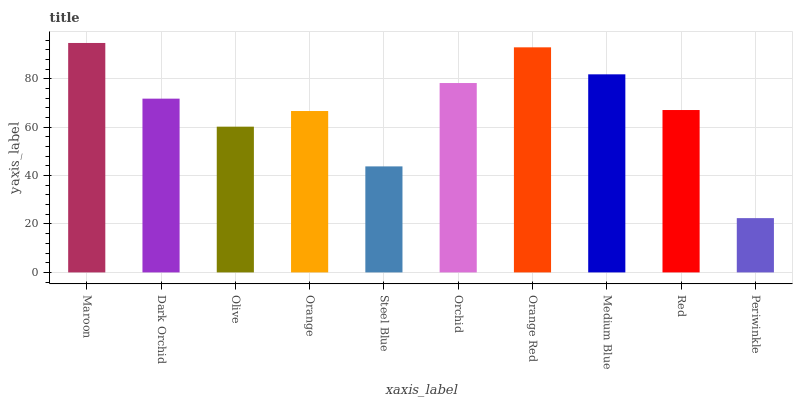Is Periwinkle the minimum?
Answer yes or no. Yes. Is Maroon the maximum?
Answer yes or no. Yes. Is Dark Orchid the minimum?
Answer yes or no. No. Is Dark Orchid the maximum?
Answer yes or no. No. Is Maroon greater than Dark Orchid?
Answer yes or no. Yes. Is Dark Orchid less than Maroon?
Answer yes or no. Yes. Is Dark Orchid greater than Maroon?
Answer yes or no. No. Is Maroon less than Dark Orchid?
Answer yes or no. No. Is Dark Orchid the high median?
Answer yes or no. Yes. Is Red the low median?
Answer yes or no. Yes. Is Orange Red the high median?
Answer yes or no. No. Is Medium Blue the low median?
Answer yes or no. No. 